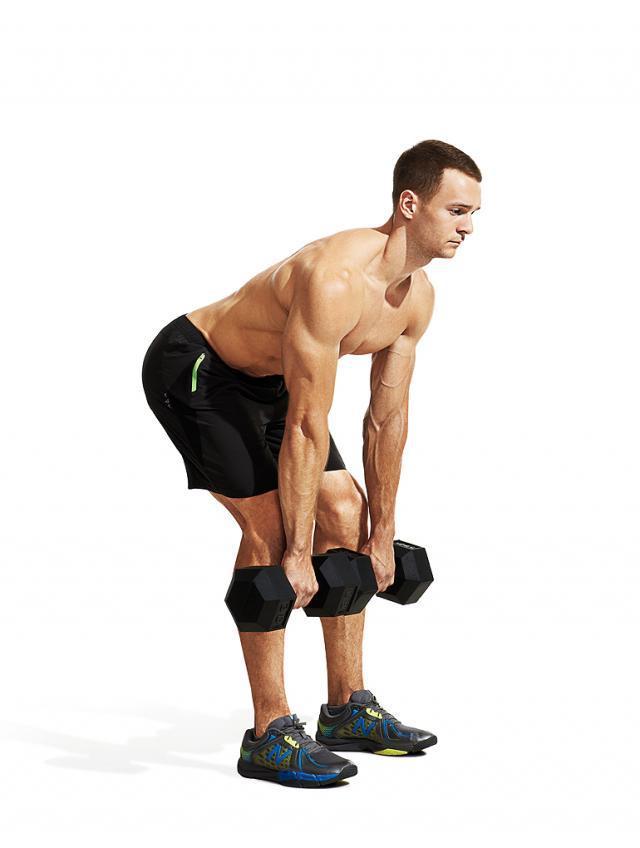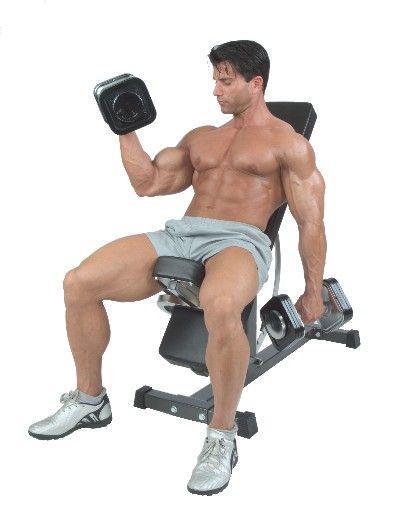The first image is the image on the left, the second image is the image on the right. Analyze the images presented: Is the assertion "There are exactly two men in the image on the right." valid? Answer yes or no. No. 